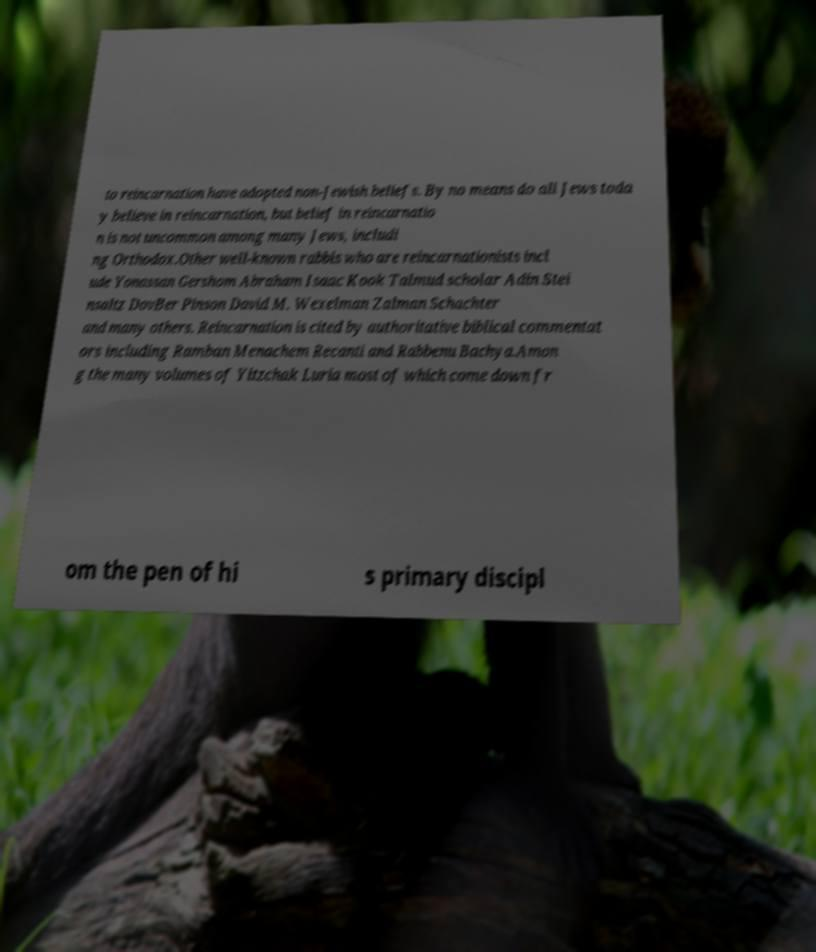Could you extract and type out the text from this image? to reincarnation have adopted non-Jewish beliefs. By no means do all Jews toda y believe in reincarnation, but belief in reincarnatio n is not uncommon among many Jews, includi ng Orthodox.Other well-known rabbis who are reincarnationists incl ude Yonassan Gershom Abraham Isaac Kook Talmud scholar Adin Stei nsaltz DovBer Pinson David M. Wexelman Zalman Schachter and many others. Reincarnation is cited by authoritative biblical commentat ors including Ramban Menachem Recanti and Rabbenu Bachya.Amon g the many volumes of Yitzchak Luria most of which come down fr om the pen of hi s primary discipl 